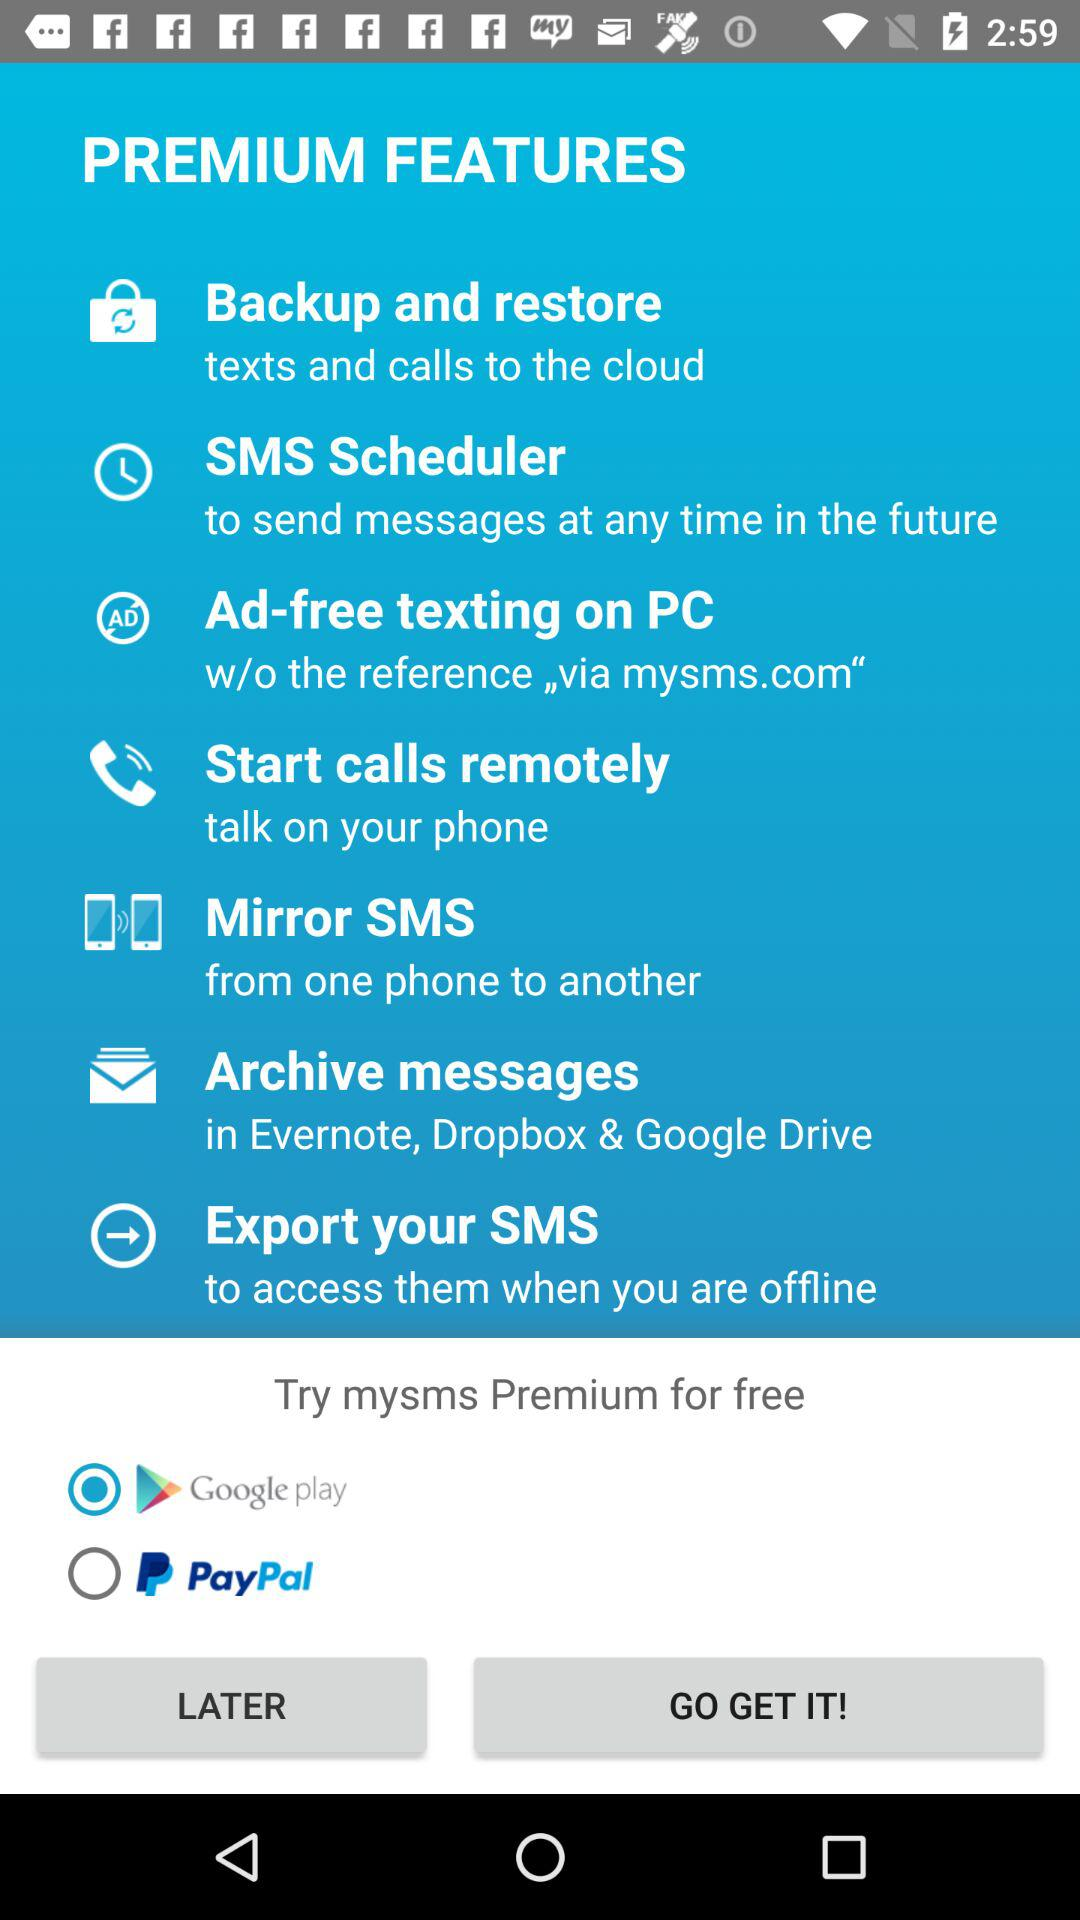What is the selected option? The selected option is "Google pay". 